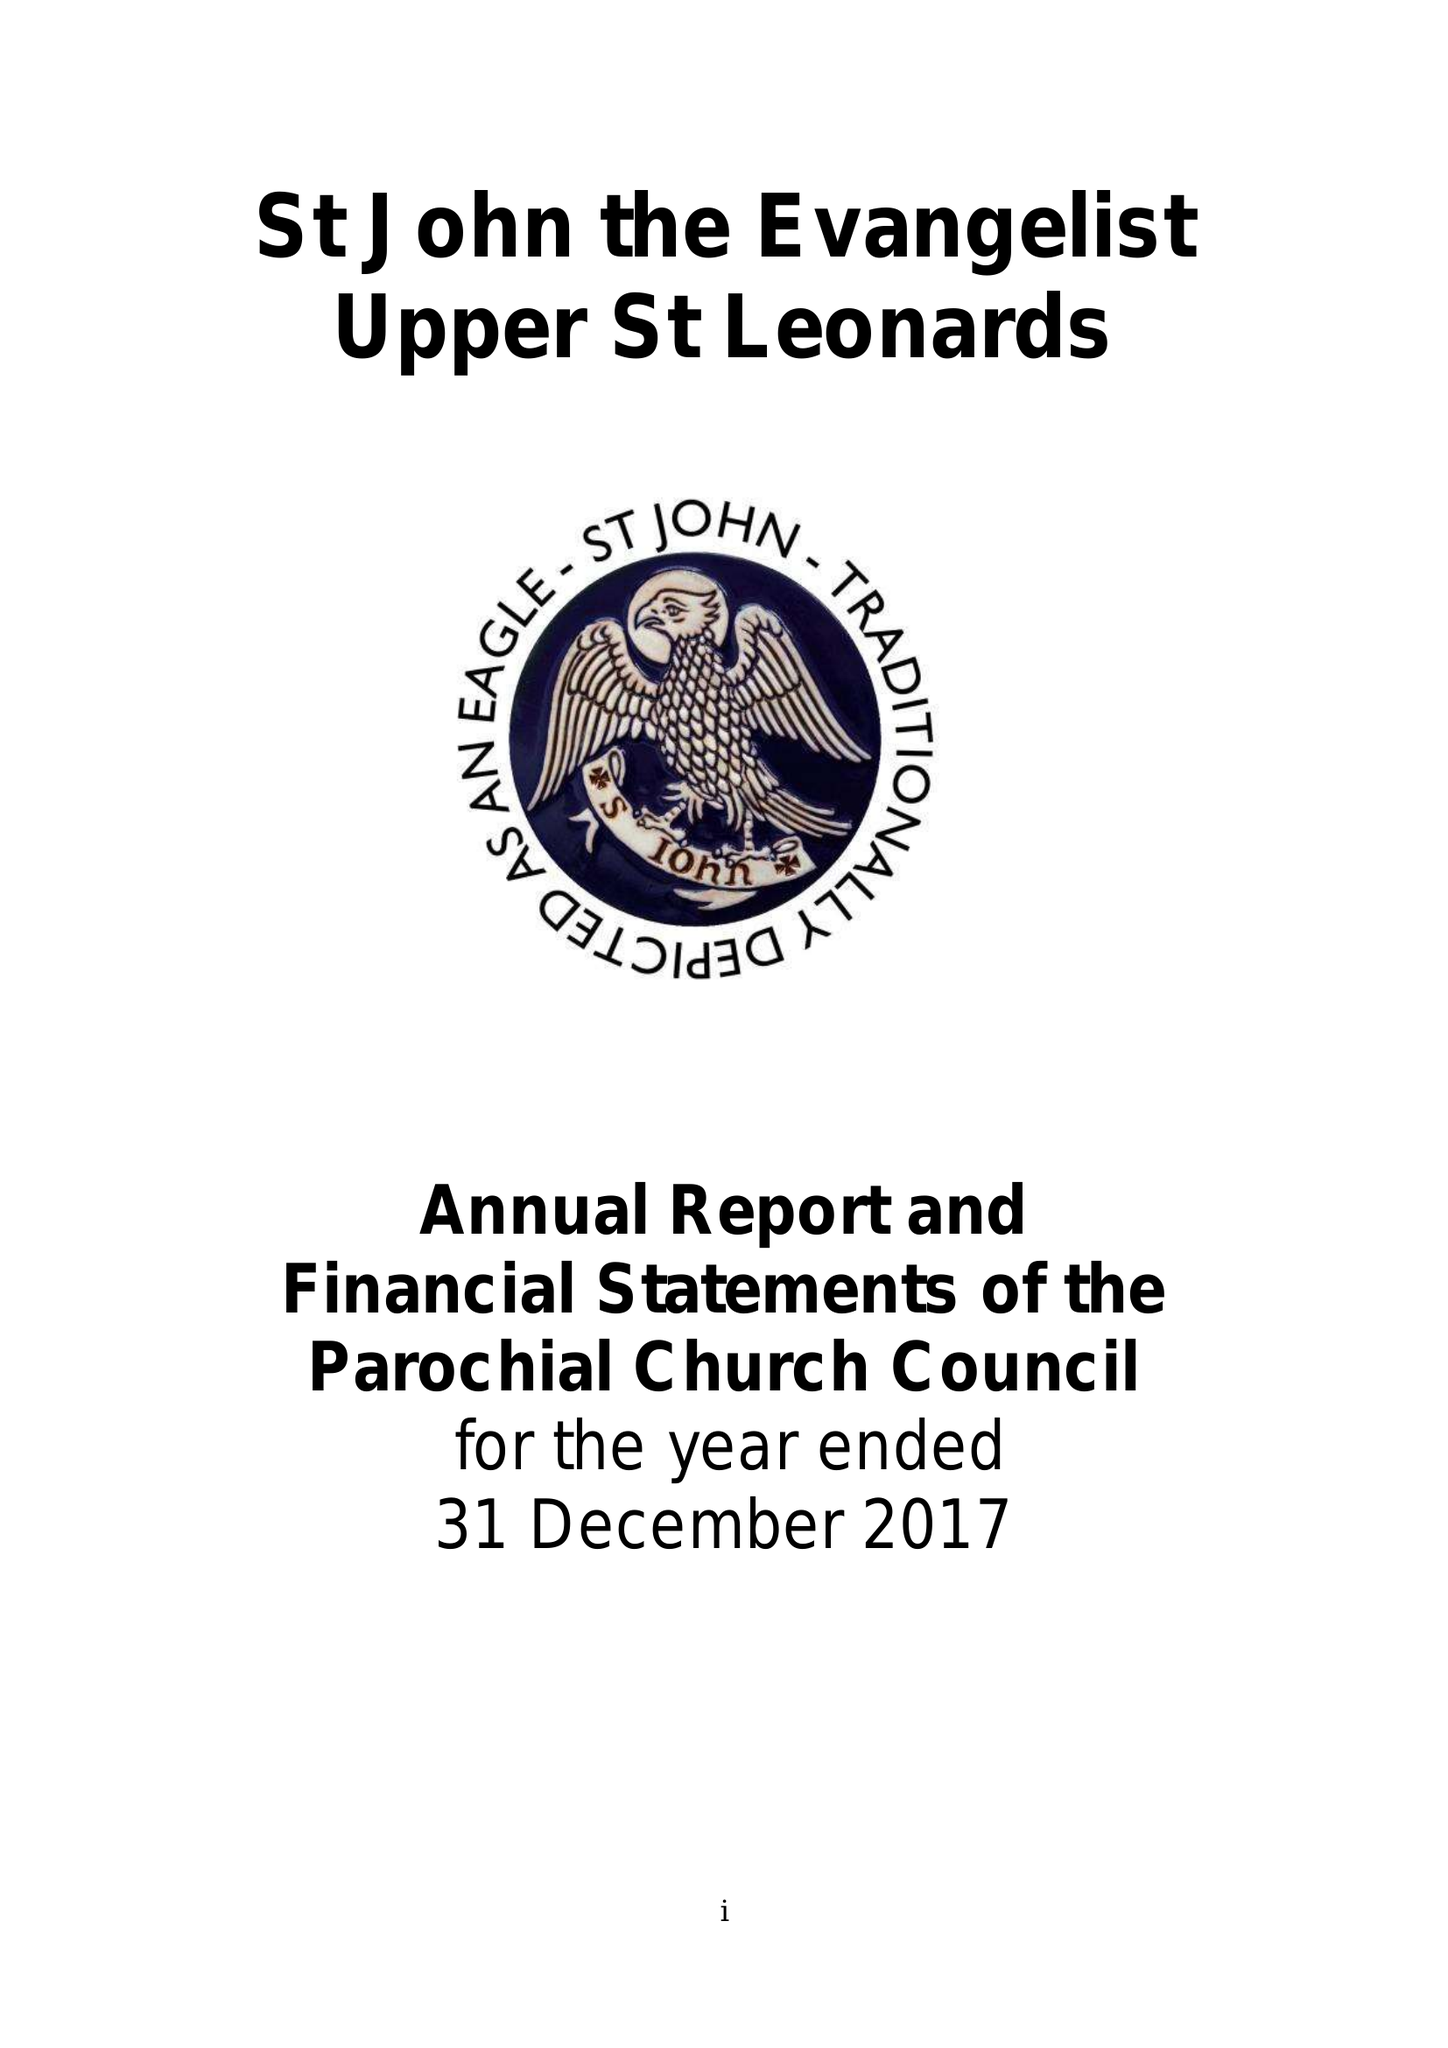What is the value for the income_annually_in_british_pounds?
Answer the question using a single word or phrase. 123726.00 